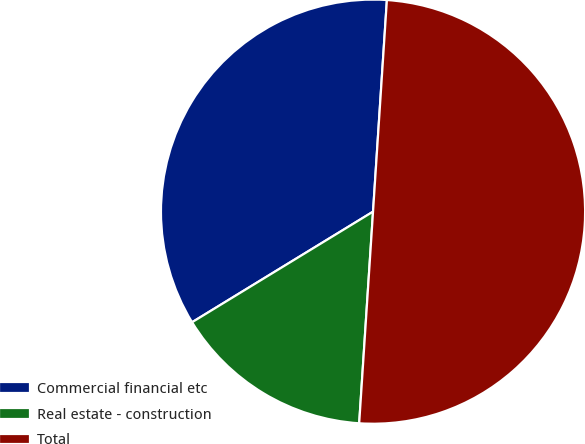<chart> <loc_0><loc_0><loc_500><loc_500><pie_chart><fcel>Commercial financial etc<fcel>Real estate - construction<fcel>Total<nl><fcel>34.77%<fcel>15.23%<fcel>50.0%<nl></chart> 